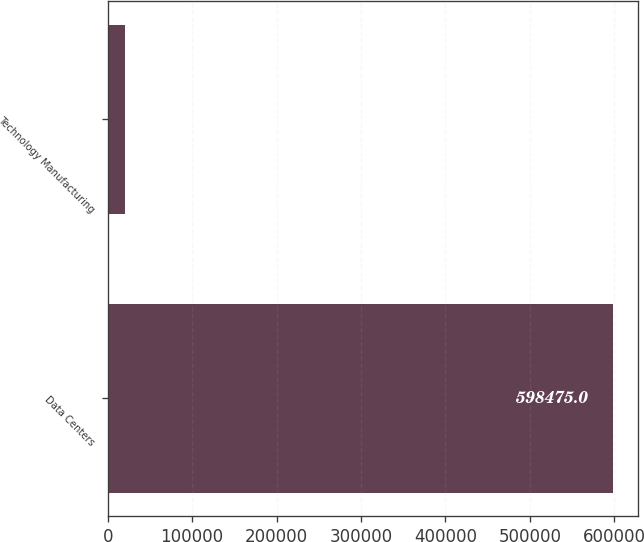Convert chart to OTSL. <chart><loc_0><loc_0><loc_500><loc_500><bar_chart><fcel>Data Centers<fcel>Technology Manufacturing<nl><fcel>598475<fcel>20199<nl></chart> 